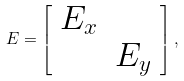<formula> <loc_0><loc_0><loc_500><loc_500>E = \left [ \begin{array} { c c } E _ { x } & \\ & E _ { y } \end{array} \right ] ,</formula> 